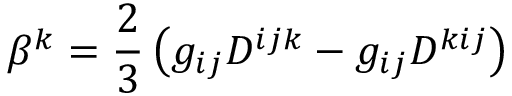<formula> <loc_0><loc_0><loc_500><loc_500>\beta ^ { k } = \frac { 2 } { 3 } \left ( g _ { i j } D ^ { i j k } - g _ { i j } D ^ { k i j } \right )</formula> 